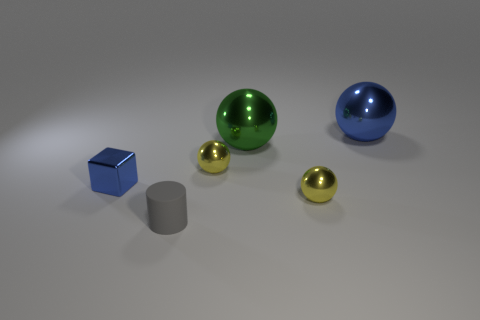Subtract 1 spheres. How many spheres are left? 3 Add 2 tiny yellow objects. How many objects exist? 8 Subtract all brown balls. Subtract all blue blocks. How many balls are left? 4 Subtract all balls. How many objects are left? 2 Subtract 1 gray cylinders. How many objects are left? 5 Subtract all big metallic objects. Subtract all blue shiny spheres. How many objects are left? 3 Add 3 small things. How many small things are left? 7 Add 1 tiny gray cylinders. How many tiny gray cylinders exist? 2 